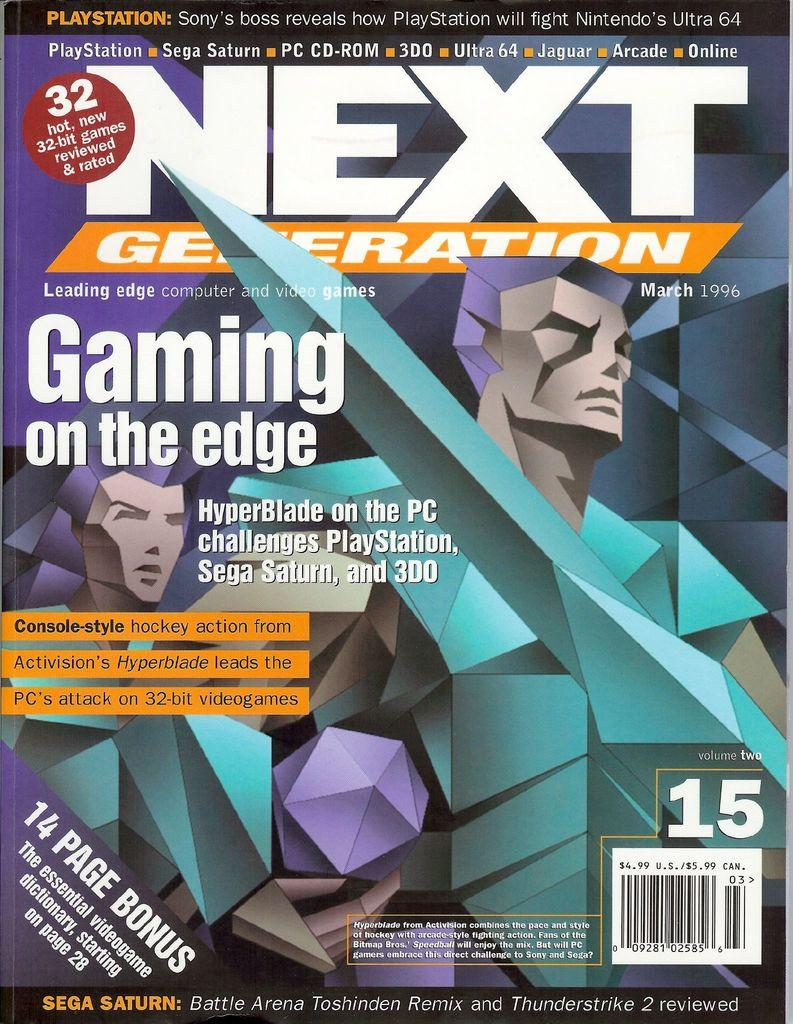<image>
Create a compact narrative representing the image presented. Activision's Hyperblade is being featured on the cover of Next Generation magazine. 